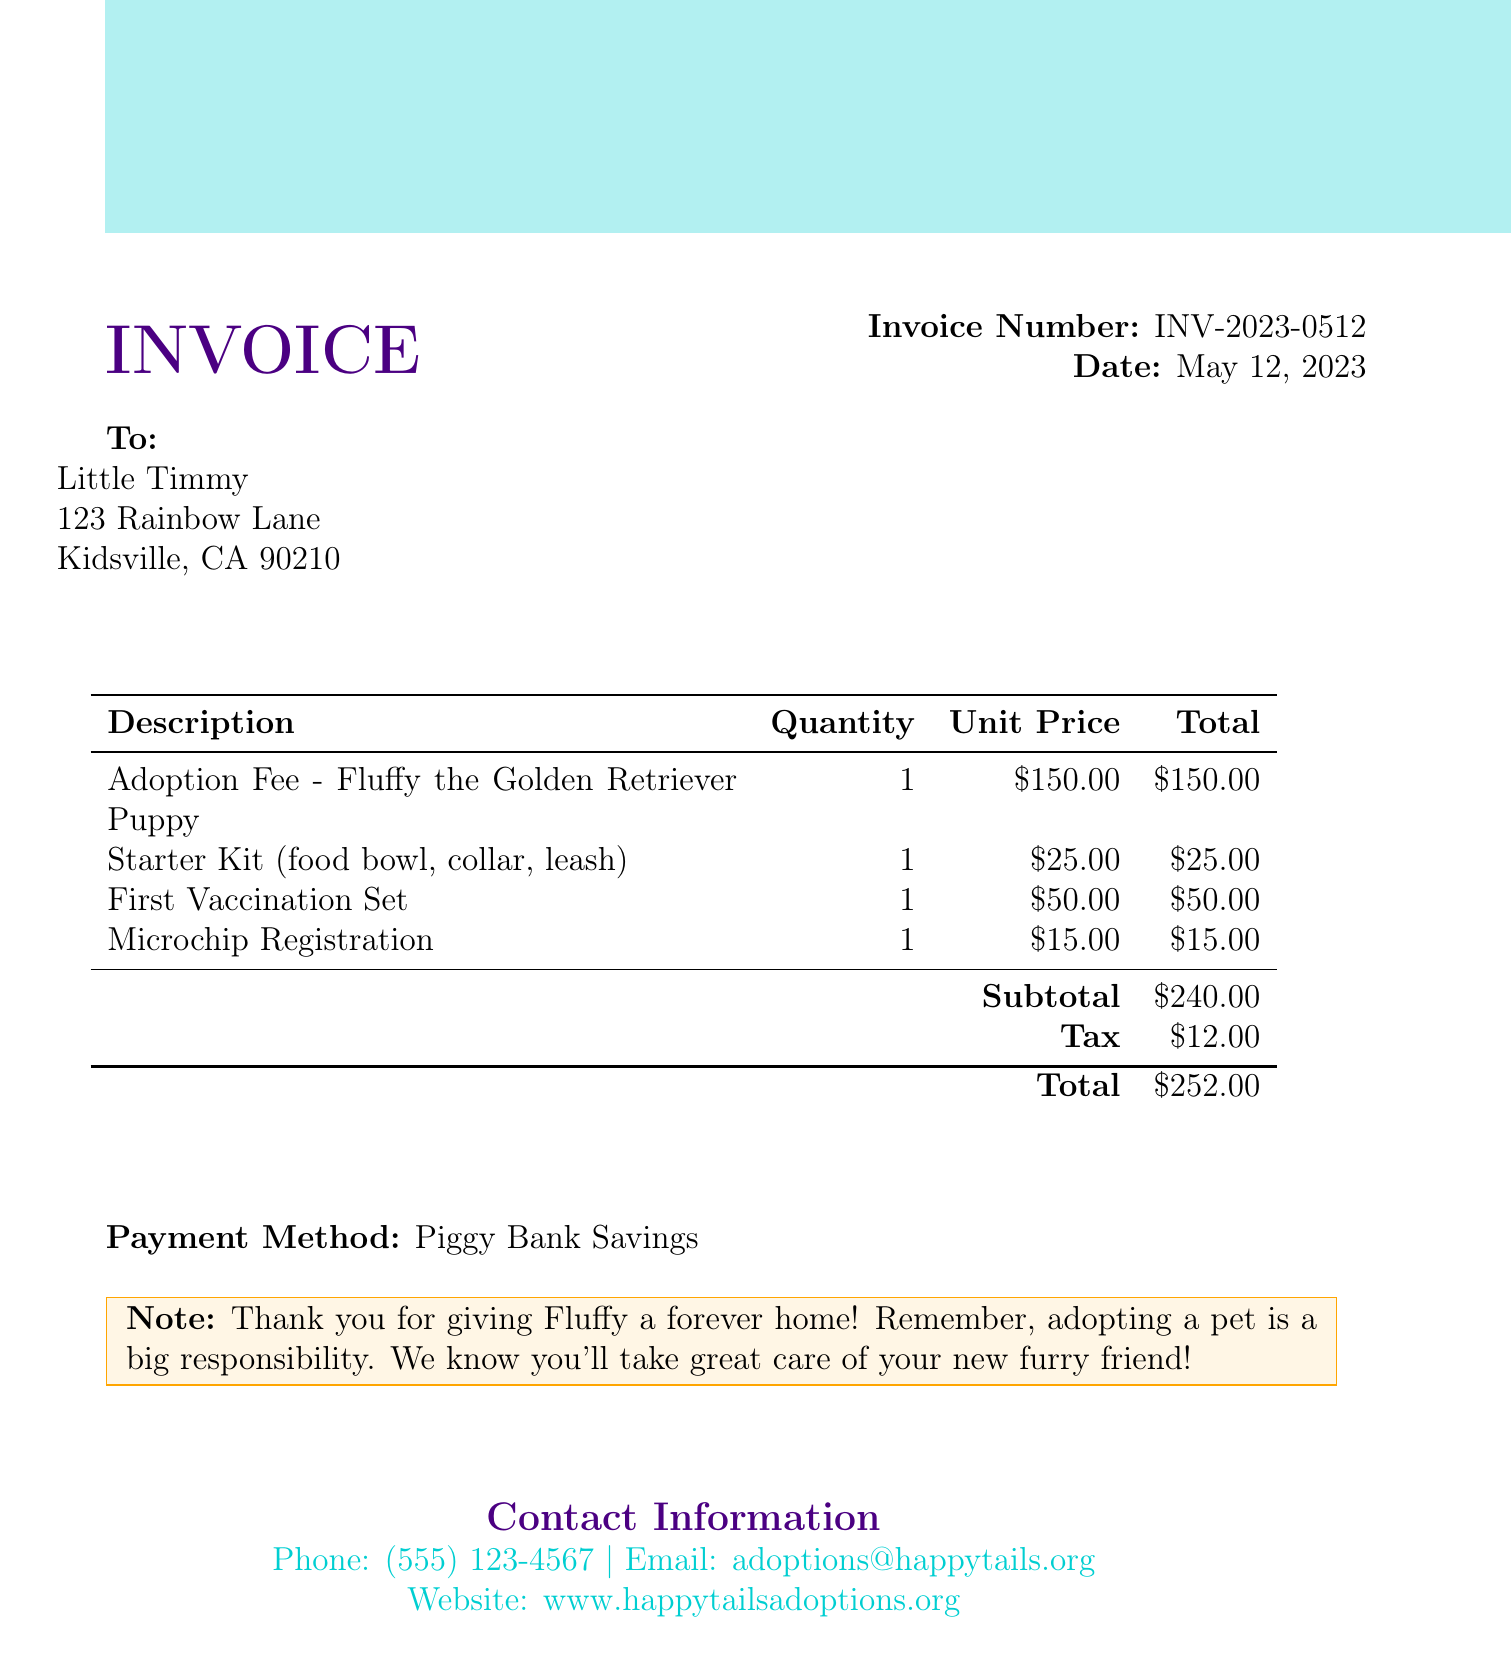What is the invoice number? The invoice number is clearly stated in the document as INV-2023-0512.
Answer: INV-2023-0512 Who is the customer? The customer name appears as "Little Timmy" in the invoice details.
Answer: Little Timmy What is the date of the invoice? The date on the invoice indicates when it was issued, which is May 12, 2023.
Answer: May 12, 2023 What is the total fee for Fluffy the Golden Retriever Puppy adoption? The total fee for adopting Fluffy, as listed in the document, is $150.00.
Answer: $150.00 What is included in the Starter Kit? The Starter Kit consists of a food bowl, collar, and leash as described in the invoice.
Answer: food bowl, collar, leash What is the subtotal amount? The subtotal amount is specified in the invoice as the total before tax, which is $240.00.
Answer: $240.00 How much did the tax amount to? The invoice clearly states that the tax on the adoption services is $12.00.
Answer: $12.00 What payment method was used? The payment method for the adoption fee is noted in the document as "Piggy Bank Savings."
Answer: Piggy Bank Savings What kind of animal is Fluffy? Fluffy is specifically identified as a Golden Retriever Puppy in the invoice.
Answer: Golden Retriever Puppy 